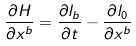<formula> <loc_0><loc_0><loc_500><loc_500>\frac { \partial H } { \partial x ^ { b } } = \frac { \partial l _ { b } } { \partial t } - \frac { \partial l _ { 0 } } { \partial x ^ { b } }</formula> 